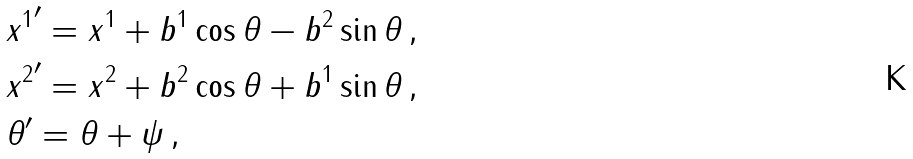<formula> <loc_0><loc_0><loc_500><loc_500>& { x ^ { 1 } } ^ { \prime } = x ^ { 1 } + b ^ { 1 } \cos \theta - b ^ { 2 } \sin \theta \, , \\ & { x ^ { 2 } } ^ { \prime } = x ^ { 2 } + b ^ { 2 } \cos \theta + b ^ { 1 } \sin \theta \, , \\ & \theta ^ { \prime } = \theta + \psi \, ,</formula> 